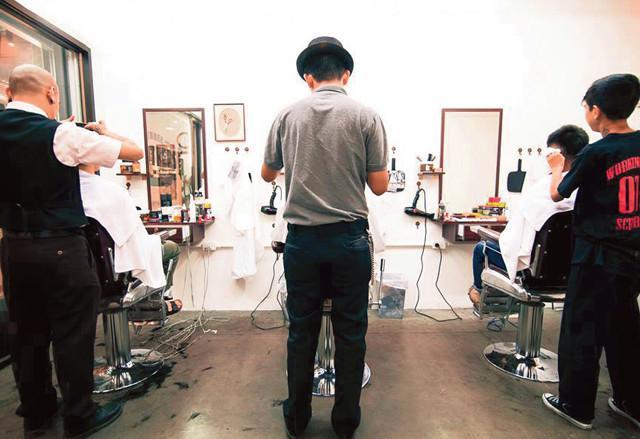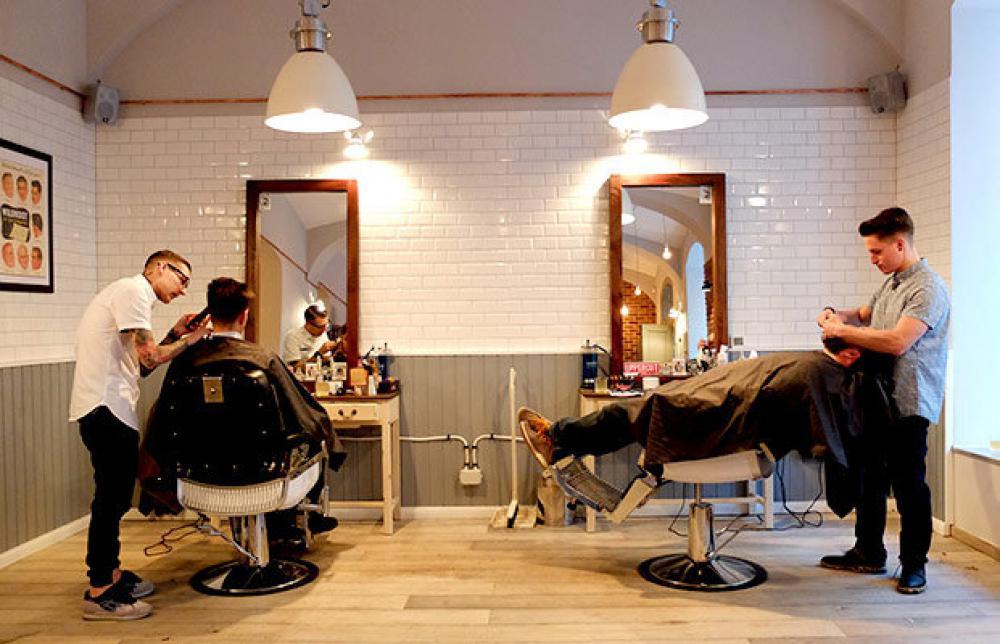The first image is the image on the left, the second image is the image on the right. Examine the images to the left and right. Is the description "Everyone is posed for the photo, nobody is going about their business." accurate? Answer yes or no. No. The first image is the image on the left, the second image is the image on the right. For the images shown, is this caption "One image shows three forward-facing men, and the man in the middle has a mustache and wears a vest." true? Answer yes or no. No. 